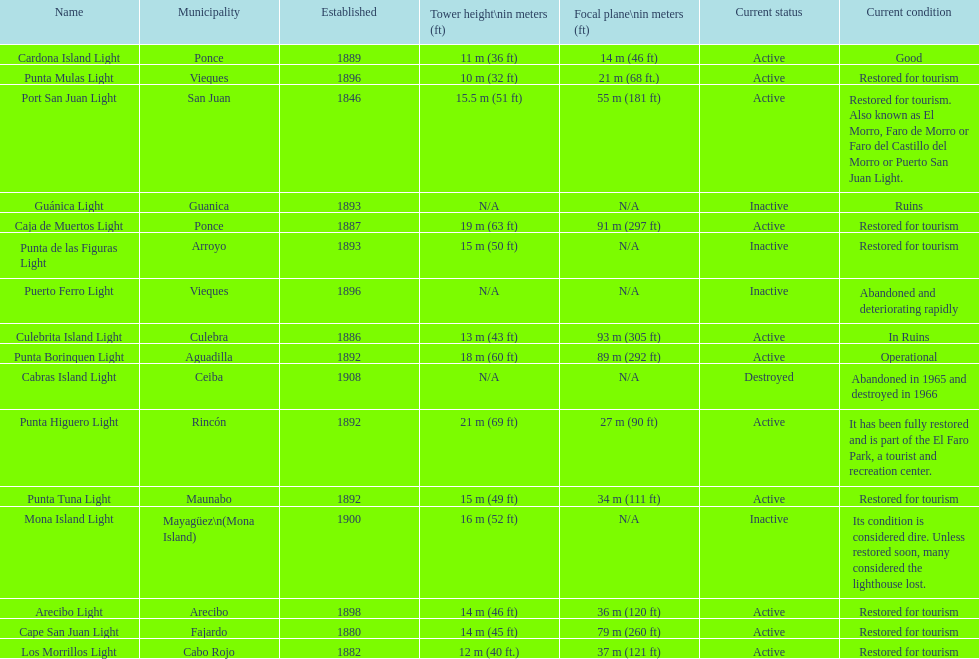What is the largest tower Punta Higuero Light. 